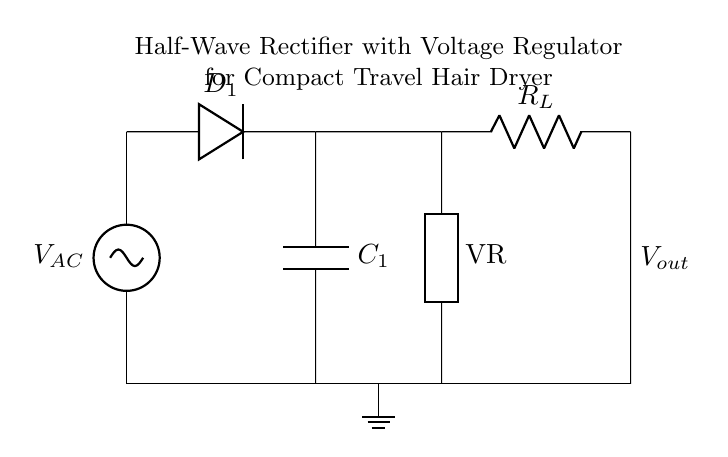What is the type of rectifier used in this circuit? The circuit diagram clearly indicates a single diode connected to the AC source, which is characteristic of a half-wave rectifier.
Answer: Half-wave rectifier What component regulates the output voltage? A component labeled 'VR' is present in the circuit, indicating a voltage regulator responsible for maintaining a steady output voltage.
Answer: Voltage regulator What is the function of the capacitor in this circuit? The capacitor, labeled as 'C1', serves to smooth the rectified output by reducing voltage ripple, allowing the output to be more stable and usable.
Answer: Smoothing What is the role of the diode in this circuit? The diode 'D1' allows current to flow in one direction only, which is essential for converting alternating current (AC) to direct current (DC) in a rectifier circuit.
Answer: Rectification What is the load represented in this circuit? The load in this circuit is denoted by 'R_L', which implies it could represent a resistive load like a heating element in a hair dryer that uses the output from the rectifier.
Answer: Load resistor How many diodes are present in the rectifier circuit? A single diode, labeled 'D1', is shown connecting the AC voltage source to the rest of the circuit, indicating that it is a half-wave design.
Answer: One diode 